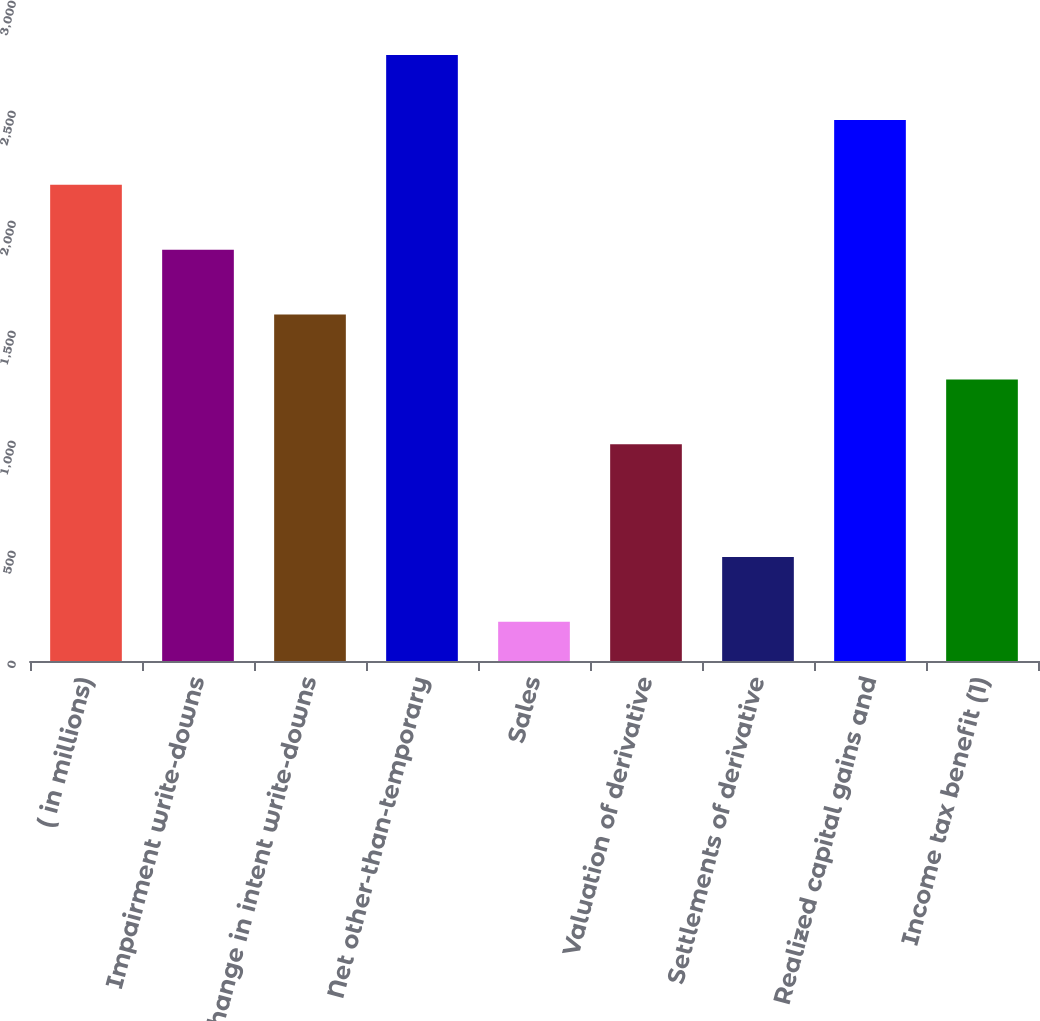Convert chart. <chart><loc_0><loc_0><loc_500><loc_500><bar_chart><fcel>( in millions)<fcel>Impairment write-downs<fcel>Change in intent write-downs<fcel>Net other-than-temporary<fcel>Sales<fcel>Valuation of derivative<fcel>Settlements of derivative<fcel>Realized capital gains and<fcel>Income tax benefit (1)<nl><fcel>2164.6<fcel>1869.7<fcel>1574.8<fcel>2754.4<fcel>178<fcel>985<fcel>472.9<fcel>2459.5<fcel>1279.9<nl></chart> 